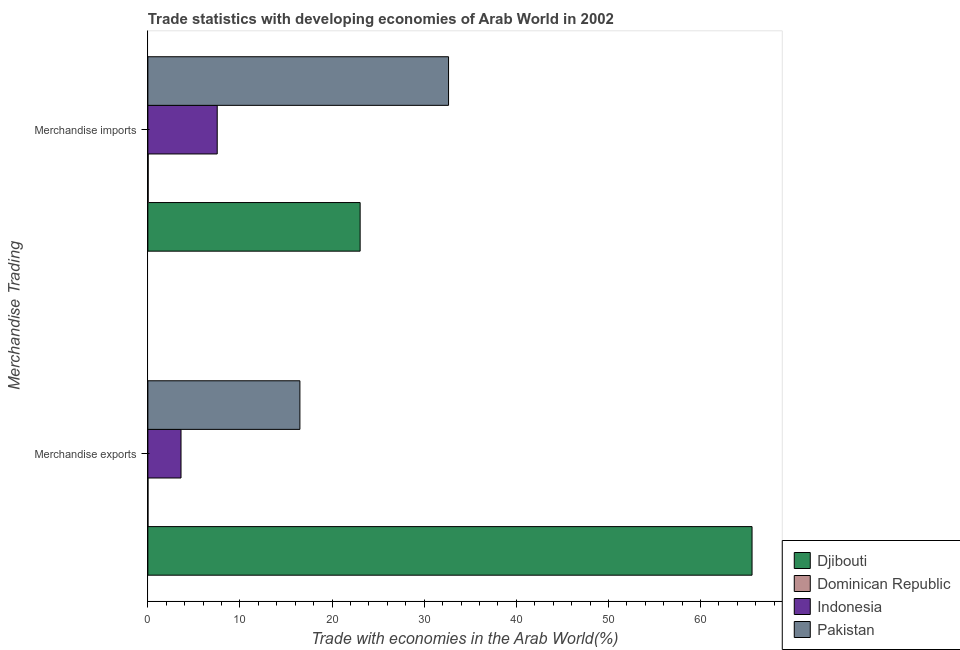How many different coloured bars are there?
Offer a terse response. 4. How many groups of bars are there?
Offer a very short reply. 2. Are the number of bars per tick equal to the number of legend labels?
Your answer should be very brief. Yes. Are the number of bars on each tick of the Y-axis equal?
Offer a very short reply. Yes. What is the merchandise exports in Indonesia?
Your response must be concise. 3.6. Across all countries, what is the maximum merchandise imports?
Your response must be concise. 32.64. Across all countries, what is the minimum merchandise imports?
Make the answer very short. 0.03. In which country was the merchandise exports maximum?
Keep it short and to the point. Djibouti. In which country was the merchandise imports minimum?
Ensure brevity in your answer.  Dominican Republic. What is the total merchandise imports in the graph?
Offer a terse response. 63.25. What is the difference between the merchandise imports in Dominican Republic and that in Djibouti?
Make the answer very short. -23.01. What is the difference between the merchandise imports in Dominican Republic and the merchandise exports in Indonesia?
Provide a short and direct response. -3.57. What is the average merchandise imports per country?
Give a very brief answer. 15.81. What is the difference between the merchandise exports and merchandise imports in Dominican Republic?
Provide a short and direct response. -0.02. In how many countries, is the merchandise imports greater than 18 %?
Keep it short and to the point. 2. What is the ratio of the merchandise exports in Dominican Republic to that in Indonesia?
Give a very brief answer. 0. Is the merchandise imports in Djibouti less than that in Pakistan?
Your answer should be very brief. Yes. What does the 4th bar from the top in Merchandise exports represents?
Keep it short and to the point. Djibouti. What does the 1st bar from the bottom in Merchandise exports represents?
Your answer should be very brief. Djibouti. How many countries are there in the graph?
Offer a very short reply. 4. What is the difference between two consecutive major ticks on the X-axis?
Provide a short and direct response. 10. Are the values on the major ticks of X-axis written in scientific E-notation?
Keep it short and to the point. No. Does the graph contain any zero values?
Make the answer very short. No. How many legend labels are there?
Your response must be concise. 4. How are the legend labels stacked?
Keep it short and to the point. Vertical. What is the title of the graph?
Ensure brevity in your answer.  Trade statistics with developing economies of Arab World in 2002. What is the label or title of the X-axis?
Provide a short and direct response. Trade with economies in the Arab World(%). What is the label or title of the Y-axis?
Provide a short and direct response. Merchandise Trading. What is the Trade with economies in the Arab World(%) in Djibouti in Merchandise exports?
Ensure brevity in your answer.  65.59. What is the Trade with economies in the Arab World(%) of Dominican Republic in Merchandise exports?
Provide a succinct answer. 0.01. What is the Trade with economies in the Arab World(%) of Indonesia in Merchandise exports?
Give a very brief answer. 3.6. What is the Trade with economies in the Arab World(%) of Pakistan in Merchandise exports?
Provide a succinct answer. 16.51. What is the Trade with economies in the Arab World(%) of Djibouti in Merchandise imports?
Offer a terse response. 23.04. What is the Trade with economies in the Arab World(%) of Dominican Republic in Merchandise imports?
Your response must be concise. 0.03. What is the Trade with economies in the Arab World(%) in Indonesia in Merchandise imports?
Keep it short and to the point. 7.53. What is the Trade with economies in the Arab World(%) in Pakistan in Merchandise imports?
Give a very brief answer. 32.64. Across all Merchandise Trading, what is the maximum Trade with economies in the Arab World(%) of Djibouti?
Ensure brevity in your answer.  65.59. Across all Merchandise Trading, what is the maximum Trade with economies in the Arab World(%) of Dominican Republic?
Provide a short and direct response. 0.03. Across all Merchandise Trading, what is the maximum Trade with economies in the Arab World(%) of Indonesia?
Keep it short and to the point. 7.53. Across all Merchandise Trading, what is the maximum Trade with economies in the Arab World(%) of Pakistan?
Keep it short and to the point. 32.64. Across all Merchandise Trading, what is the minimum Trade with economies in the Arab World(%) in Djibouti?
Provide a short and direct response. 23.04. Across all Merchandise Trading, what is the minimum Trade with economies in the Arab World(%) of Dominican Republic?
Your response must be concise. 0.01. Across all Merchandise Trading, what is the minimum Trade with economies in the Arab World(%) of Indonesia?
Provide a succinct answer. 3.6. Across all Merchandise Trading, what is the minimum Trade with economies in the Arab World(%) in Pakistan?
Ensure brevity in your answer.  16.51. What is the total Trade with economies in the Arab World(%) in Djibouti in the graph?
Ensure brevity in your answer.  88.64. What is the total Trade with economies in the Arab World(%) in Dominican Republic in the graph?
Keep it short and to the point. 0.04. What is the total Trade with economies in the Arab World(%) of Indonesia in the graph?
Ensure brevity in your answer.  11.13. What is the total Trade with economies in the Arab World(%) in Pakistan in the graph?
Offer a terse response. 49.15. What is the difference between the Trade with economies in the Arab World(%) in Djibouti in Merchandise exports and that in Merchandise imports?
Keep it short and to the point. 42.55. What is the difference between the Trade with economies in the Arab World(%) in Dominican Republic in Merchandise exports and that in Merchandise imports?
Offer a terse response. -0.02. What is the difference between the Trade with economies in the Arab World(%) of Indonesia in Merchandise exports and that in Merchandise imports?
Make the answer very short. -3.93. What is the difference between the Trade with economies in the Arab World(%) in Pakistan in Merchandise exports and that in Merchandise imports?
Keep it short and to the point. -16.14. What is the difference between the Trade with economies in the Arab World(%) of Djibouti in Merchandise exports and the Trade with economies in the Arab World(%) of Dominican Republic in Merchandise imports?
Your answer should be very brief. 65.56. What is the difference between the Trade with economies in the Arab World(%) of Djibouti in Merchandise exports and the Trade with economies in the Arab World(%) of Indonesia in Merchandise imports?
Ensure brevity in your answer.  58.06. What is the difference between the Trade with economies in the Arab World(%) of Djibouti in Merchandise exports and the Trade with economies in the Arab World(%) of Pakistan in Merchandise imports?
Provide a short and direct response. 32.95. What is the difference between the Trade with economies in the Arab World(%) in Dominican Republic in Merchandise exports and the Trade with economies in the Arab World(%) in Indonesia in Merchandise imports?
Provide a succinct answer. -7.52. What is the difference between the Trade with economies in the Arab World(%) in Dominican Republic in Merchandise exports and the Trade with economies in the Arab World(%) in Pakistan in Merchandise imports?
Give a very brief answer. -32.63. What is the difference between the Trade with economies in the Arab World(%) in Indonesia in Merchandise exports and the Trade with economies in the Arab World(%) in Pakistan in Merchandise imports?
Your answer should be very brief. -29.04. What is the average Trade with economies in the Arab World(%) of Djibouti per Merchandise Trading?
Your response must be concise. 44.32. What is the average Trade with economies in the Arab World(%) of Dominican Republic per Merchandise Trading?
Provide a succinct answer. 0.02. What is the average Trade with economies in the Arab World(%) in Indonesia per Merchandise Trading?
Your answer should be compact. 5.56. What is the average Trade with economies in the Arab World(%) in Pakistan per Merchandise Trading?
Provide a short and direct response. 24.57. What is the difference between the Trade with economies in the Arab World(%) of Djibouti and Trade with economies in the Arab World(%) of Dominican Republic in Merchandise exports?
Give a very brief answer. 65.58. What is the difference between the Trade with economies in the Arab World(%) in Djibouti and Trade with economies in the Arab World(%) in Indonesia in Merchandise exports?
Offer a terse response. 61.99. What is the difference between the Trade with economies in the Arab World(%) in Djibouti and Trade with economies in the Arab World(%) in Pakistan in Merchandise exports?
Provide a short and direct response. 49.09. What is the difference between the Trade with economies in the Arab World(%) in Dominican Republic and Trade with economies in the Arab World(%) in Indonesia in Merchandise exports?
Your answer should be compact. -3.59. What is the difference between the Trade with economies in the Arab World(%) of Dominican Republic and Trade with economies in the Arab World(%) of Pakistan in Merchandise exports?
Ensure brevity in your answer.  -16.5. What is the difference between the Trade with economies in the Arab World(%) of Indonesia and Trade with economies in the Arab World(%) of Pakistan in Merchandise exports?
Keep it short and to the point. -12.91. What is the difference between the Trade with economies in the Arab World(%) in Djibouti and Trade with economies in the Arab World(%) in Dominican Republic in Merchandise imports?
Offer a very short reply. 23.01. What is the difference between the Trade with economies in the Arab World(%) of Djibouti and Trade with economies in the Arab World(%) of Indonesia in Merchandise imports?
Your answer should be very brief. 15.52. What is the difference between the Trade with economies in the Arab World(%) in Djibouti and Trade with economies in the Arab World(%) in Pakistan in Merchandise imports?
Your answer should be compact. -9.6. What is the difference between the Trade with economies in the Arab World(%) of Dominican Republic and Trade with economies in the Arab World(%) of Indonesia in Merchandise imports?
Give a very brief answer. -7.5. What is the difference between the Trade with economies in the Arab World(%) of Dominican Republic and Trade with economies in the Arab World(%) of Pakistan in Merchandise imports?
Ensure brevity in your answer.  -32.61. What is the difference between the Trade with economies in the Arab World(%) in Indonesia and Trade with economies in the Arab World(%) in Pakistan in Merchandise imports?
Make the answer very short. -25.11. What is the ratio of the Trade with economies in the Arab World(%) in Djibouti in Merchandise exports to that in Merchandise imports?
Keep it short and to the point. 2.85. What is the ratio of the Trade with economies in the Arab World(%) of Dominican Republic in Merchandise exports to that in Merchandise imports?
Ensure brevity in your answer.  0.25. What is the ratio of the Trade with economies in the Arab World(%) in Indonesia in Merchandise exports to that in Merchandise imports?
Give a very brief answer. 0.48. What is the ratio of the Trade with economies in the Arab World(%) in Pakistan in Merchandise exports to that in Merchandise imports?
Your response must be concise. 0.51. What is the difference between the highest and the second highest Trade with economies in the Arab World(%) in Djibouti?
Your response must be concise. 42.55. What is the difference between the highest and the second highest Trade with economies in the Arab World(%) in Dominican Republic?
Your answer should be compact. 0.02. What is the difference between the highest and the second highest Trade with economies in the Arab World(%) of Indonesia?
Your response must be concise. 3.93. What is the difference between the highest and the second highest Trade with economies in the Arab World(%) in Pakistan?
Provide a succinct answer. 16.14. What is the difference between the highest and the lowest Trade with economies in the Arab World(%) of Djibouti?
Offer a very short reply. 42.55. What is the difference between the highest and the lowest Trade with economies in the Arab World(%) in Dominican Republic?
Offer a terse response. 0.02. What is the difference between the highest and the lowest Trade with economies in the Arab World(%) in Indonesia?
Offer a terse response. 3.93. What is the difference between the highest and the lowest Trade with economies in the Arab World(%) of Pakistan?
Keep it short and to the point. 16.14. 